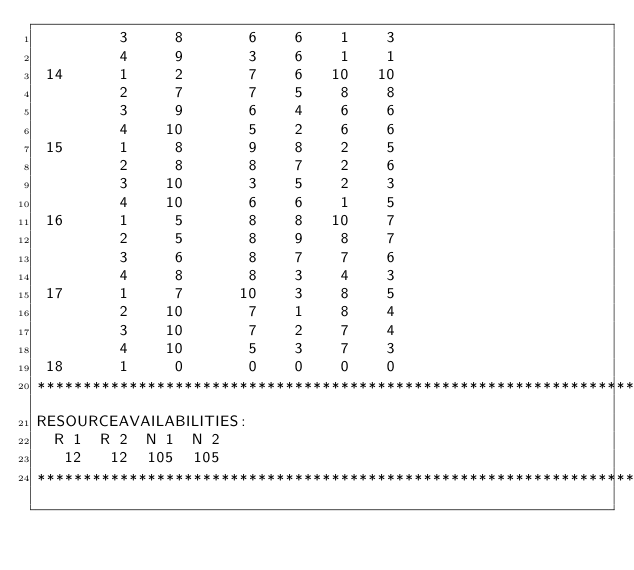Convert code to text. <code><loc_0><loc_0><loc_500><loc_500><_ObjectiveC_>         3     8       6    6    1    3
         4     9       3    6    1    1
 14      1     2       7    6   10   10
         2     7       7    5    8    8
         3     9       6    4    6    6
         4    10       5    2    6    6
 15      1     8       9    8    2    5
         2     8       8    7    2    6
         3    10       3    5    2    3
         4    10       6    6    1    5
 16      1     5       8    8   10    7
         2     5       8    9    8    7
         3     6       8    7    7    6
         4     8       8    3    4    3
 17      1     7      10    3    8    5
         2    10       7    1    8    4
         3    10       7    2    7    4
         4    10       5    3    7    3
 18      1     0       0    0    0    0
************************************************************************
RESOURCEAVAILABILITIES:
  R 1  R 2  N 1  N 2
   12   12  105  105
************************************************************************
</code> 